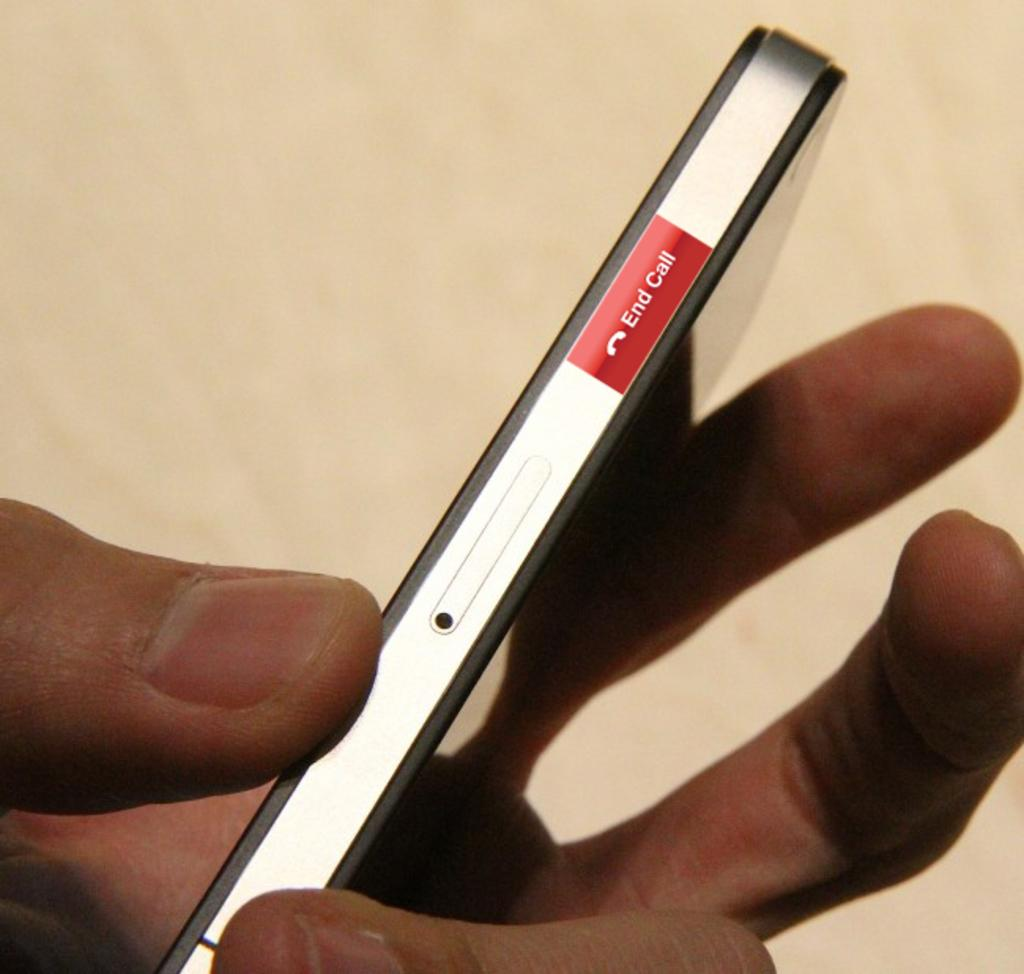Provide a one-sentence caption for the provided image. a hand holding a cell phone with an end call button on the side. 